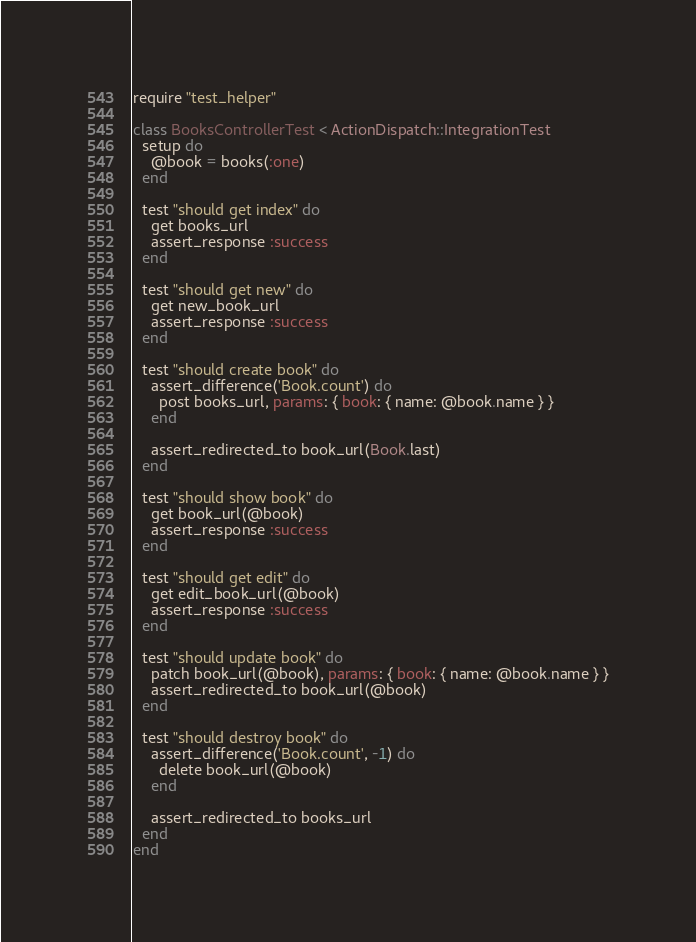<code> <loc_0><loc_0><loc_500><loc_500><_Ruby_>require "test_helper"

class BooksControllerTest < ActionDispatch::IntegrationTest
  setup do
    @book = books(:one)
  end

  test "should get index" do
    get books_url
    assert_response :success
  end

  test "should get new" do
    get new_book_url
    assert_response :success
  end

  test "should create book" do
    assert_difference('Book.count') do
      post books_url, params: { book: { name: @book.name } }
    end

    assert_redirected_to book_url(Book.last)
  end

  test "should show book" do
    get book_url(@book)
    assert_response :success
  end

  test "should get edit" do
    get edit_book_url(@book)
    assert_response :success
  end

  test "should update book" do
    patch book_url(@book), params: { book: { name: @book.name } }
    assert_redirected_to book_url(@book)
  end

  test "should destroy book" do
    assert_difference('Book.count', -1) do
      delete book_url(@book)
    end

    assert_redirected_to books_url
  end
end
</code> 